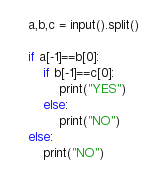Convert code to text. <code><loc_0><loc_0><loc_500><loc_500><_Python_>a,b,c = input().split()

if a[-1]==b[0]:
    if b[-1]==c[0]:
        print("YES")
    else:
        print("NO")
else:
    print("NO")</code> 